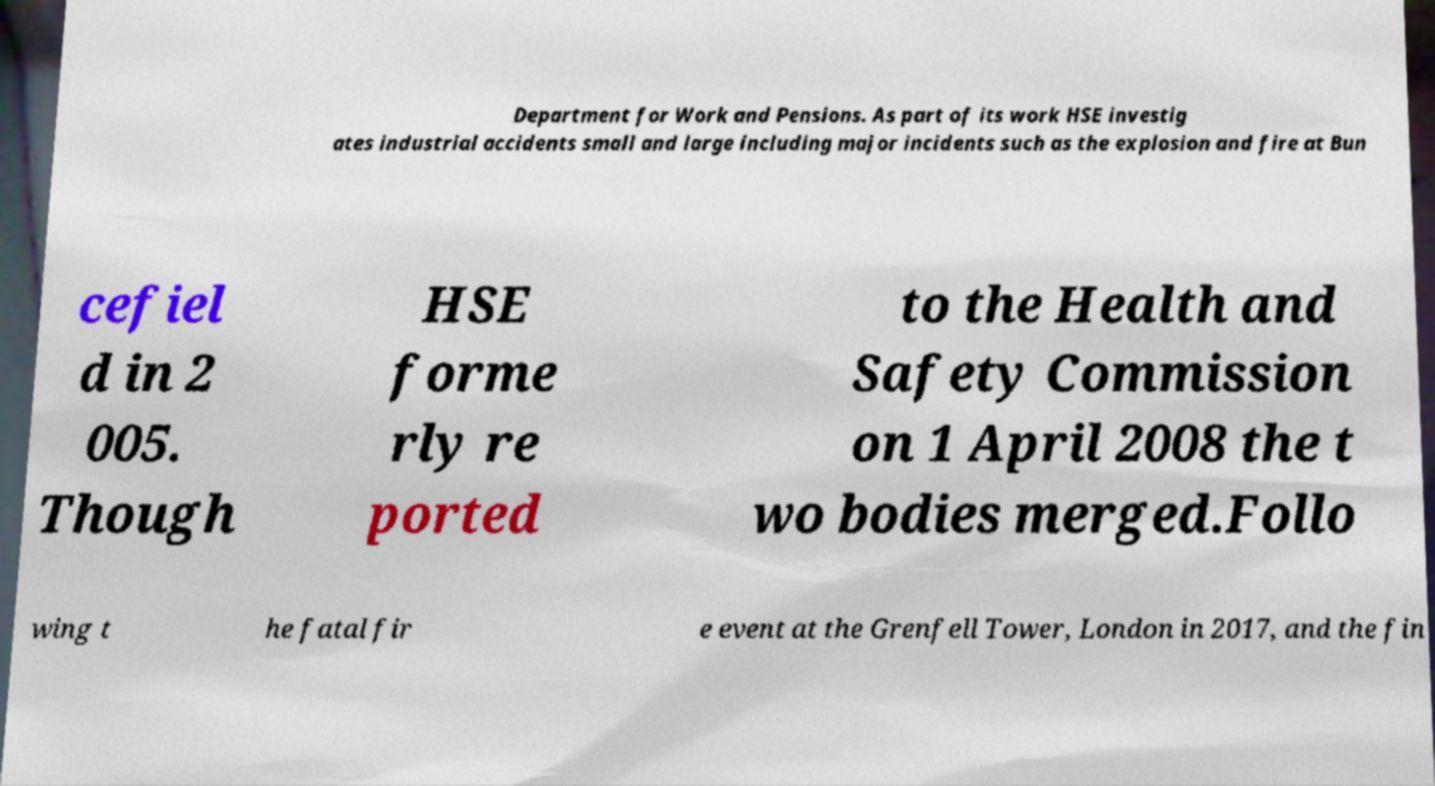Can you accurately transcribe the text from the provided image for me? Department for Work and Pensions. As part of its work HSE investig ates industrial accidents small and large including major incidents such as the explosion and fire at Bun cefiel d in 2 005. Though HSE forme rly re ported to the Health and Safety Commission on 1 April 2008 the t wo bodies merged.Follo wing t he fatal fir e event at the Grenfell Tower, London in 2017, and the fin 